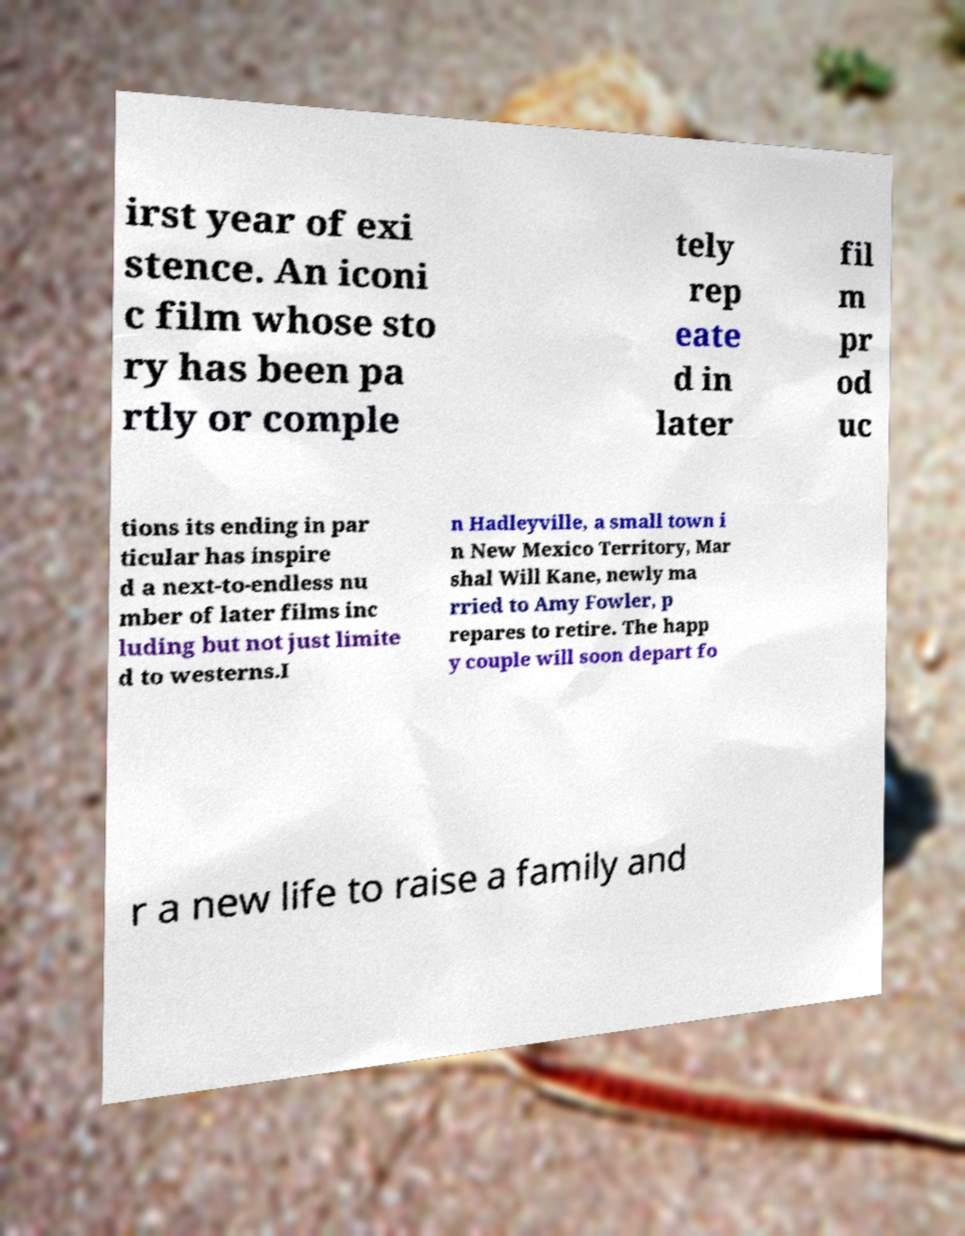Can you accurately transcribe the text from the provided image for me? irst year of exi stence. An iconi c film whose sto ry has been pa rtly or comple tely rep eate d in later fil m pr od uc tions its ending in par ticular has inspire d a next-to-endless nu mber of later films inc luding but not just limite d to westerns.I n Hadleyville, a small town i n New Mexico Territory, Mar shal Will Kane, newly ma rried to Amy Fowler, p repares to retire. The happ y couple will soon depart fo r a new life to raise a family and 